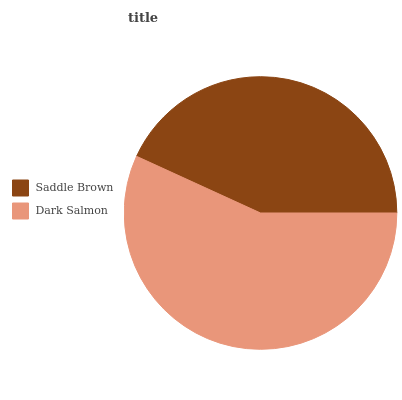Is Saddle Brown the minimum?
Answer yes or no. Yes. Is Dark Salmon the maximum?
Answer yes or no. Yes. Is Dark Salmon the minimum?
Answer yes or no. No. Is Dark Salmon greater than Saddle Brown?
Answer yes or no. Yes. Is Saddle Brown less than Dark Salmon?
Answer yes or no. Yes. Is Saddle Brown greater than Dark Salmon?
Answer yes or no. No. Is Dark Salmon less than Saddle Brown?
Answer yes or no. No. Is Dark Salmon the high median?
Answer yes or no. Yes. Is Saddle Brown the low median?
Answer yes or no. Yes. Is Saddle Brown the high median?
Answer yes or no. No. Is Dark Salmon the low median?
Answer yes or no. No. 